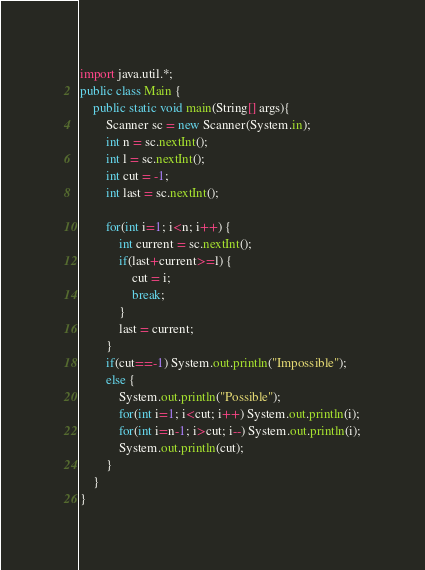<code> <loc_0><loc_0><loc_500><loc_500><_Java_>import java.util.*;
public class Main {
	public static void main(String[] args){
		Scanner sc = new Scanner(System.in);
		int n = sc.nextInt();
		int l = sc.nextInt();
		int cut = -1;
		int last = sc.nextInt();

		for(int i=1; i<n; i++) {
			int current = sc.nextInt();
			if(last+current>=l) {
				cut = i;
				break;
			}
			last = current;
		}
		if(cut==-1) System.out.println("Impossible");
		else {
			System.out.println("Possible");
			for(int i=1; i<cut; i++) System.out.println(i);
			for(int i=n-1; i>cut; i--) System.out.println(i);
			System.out.println(cut); 
		}
	}
}</code> 